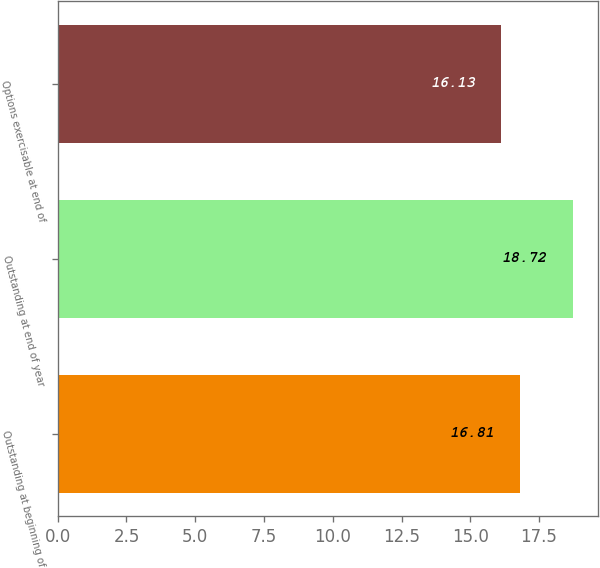Convert chart. <chart><loc_0><loc_0><loc_500><loc_500><bar_chart><fcel>Outstanding at beginning of<fcel>Outstanding at end of year<fcel>Options exercisable at end of<nl><fcel>16.81<fcel>18.72<fcel>16.13<nl></chart> 